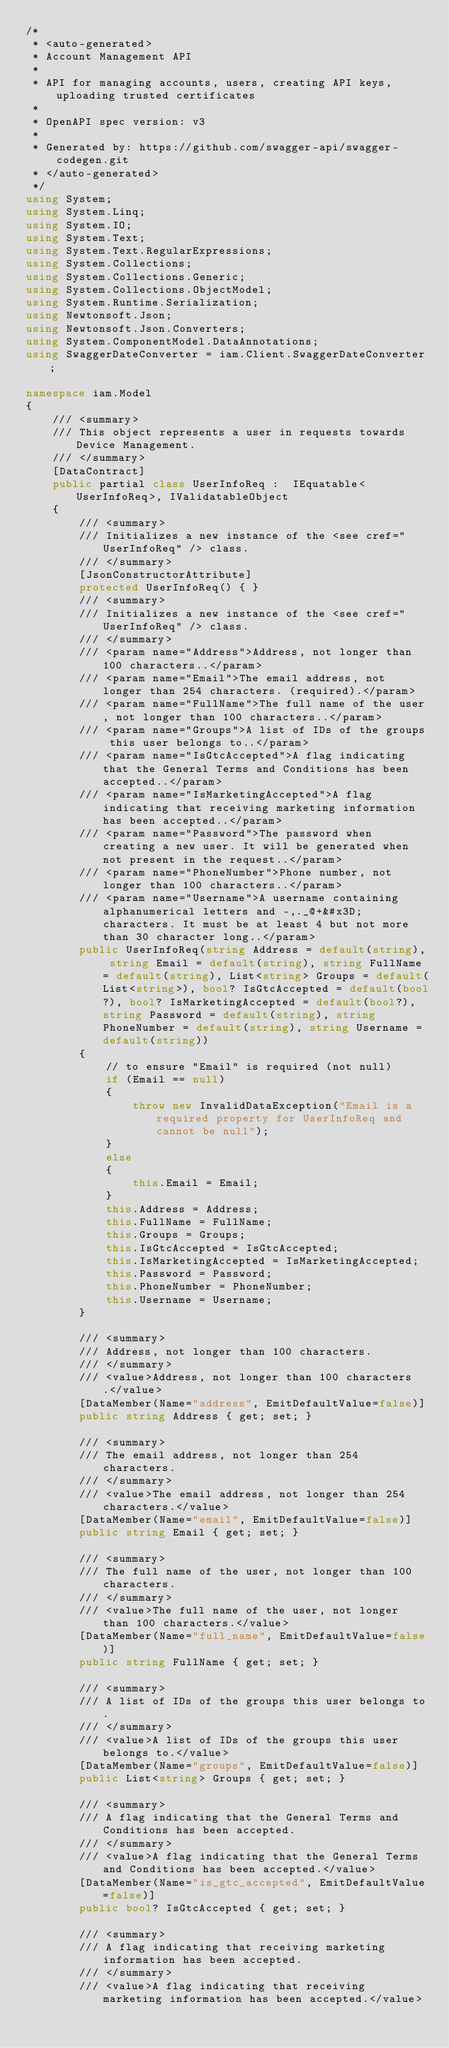Convert code to text. <code><loc_0><loc_0><loc_500><loc_500><_C#_>/* 
 * <auto-generated>
 * Account Management API
 *
 * API for managing accounts, users, creating API keys, uploading trusted certificates
 *
 * OpenAPI spec version: v3
 * 
 * Generated by: https://github.com/swagger-api/swagger-codegen.git
 * </auto-generated>
 */
using System;
using System.Linq;
using System.IO;
using System.Text;
using System.Text.RegularExpressions;
using System.Collections;
using System.Collections.Generic;
using System.Collections.ObjectModel;
using System.Runtime.Serialization;
using Newtonsoft.Json;
using Newtonsoft.Json.Converters;
using System.ComponentModel.DataAnnotations;
using SwaggerDateConverter = iam.Client.SwaggerDateConverter;

namespace iam.Model
{
    /// <summary>
    /// This object represents a user in requests towards Device Management.
    /// </summary>
    [DataContract]
    public partial class UserInfoReq :  IEquatable<UserInfoReq>, IValidatableObject
    {
        /// <summary>
        /// Initializes a new instance of the <see cref="UserInfoReq" /> class.
        /// </summary>
        [JsonConstructorAttribute]
        protected UserInfoReq() { }
        /// <summary>
        /// Initializes a new instance of the <see cref="UserInfoReq" /> class.
        /// </summary>
        /// <param name="Address">Address, not longer than 100 characters..</param>
        /// <param name="Email">The email address, not longer than 254 characters. (required).</param>
        /// <param name="FullName">The full name of the user, not longer than 100 characters..</param>
        /// <param name="Groups">A list of IDs of the groups this user belongs to..</param>
        /// <param name="IsGtcAccepted">A flag indicating that the General Terms and Conditions has been accepted..</param>
        /// <param name="IsMarketingAccepted">A flag indicating that receiving marketing information has been accepted..</param>
        /// <param name="Password">The password when creating a new user. It will be generated when not present in the request..</param>
        /// <param name="PhoneNumber">Phone number, not longer than 100 characters..</param>
        /// <param name="Username">A username containing alphanumerical letters and -,._@+&#x3D; characters. It must be at least 4 but not more than 30 character long..</param>
        public UserInfoReq(string Address = default(string), string Email = default(string), string FullName = default(string), List<string> Groups = default(List<string>), bool? IsGtcAccepted = default(bool?), bool? IsMarketingAccepted = default(bool?), string Password = default(string), string PhoneNumber = default(string), string Username = default(string))
        {
            // to ensure "Email" is required (not null)
            if (Email == null)
            {
                throw new InvalidDataException("Email is a required property for UserInfoReq and cannot be null");
            }
            else
            {
                this.Email = Email;
            }
            this.Address = Address;
            this.FullName = FullName;
            this.Groups = Groups;
            this.IsGtcAccepted = IsGtcAccepted;
            this.IsMarketingAccepted = IsMarketingAccepted;
            this.Password = Password;
            this.PhoneNumber = PhoneNumber;
            this.Username = Username;
        }
        
        /// <summary>
        /// Address, not longer than 100 characters.
        /// </summary>
        /// <value>Address, not longer than 100 characters.</value>
        [DataMember(Name="address", EmitDefaultValue=false)]
        public string Address { get; set; }

        /// <summary>
        /// The email address, not longer than 254 characters.
        /// </summary>
        /// <value>The email address, not longer than 254 characters.</value>
        [DataMember(Name="email", EmitDefaultValue=false)]
        public string Email { get; set; }

        /// <summary>
        /// The full name of the user, not longer than 100 characters.
        /// </summary>
        /// <value>The full name of the user, not longer than 100 characters.</value>
        [DataMember(Name="full_name", EmitDefaultValue=false)]
        public string FullName { get; set; }

        /// <summary>
        /// A list of IDs of the groups this user belongs to.
        /// </summary>
        /// <value>A list of IDs of the groups this user belongs to.</value>
        [DataMember(Name="groups", EmitDefaultValue=false)]
        public List<string> Groups { get; set; }

        /// <summary>
        /// A flag indicating that the General Terms and Conditions has been accepted.
        /// </summary>
        /// <value>A flag indicating that the General Terms and Conditions has been accepted.</value>
        [DataMember(Name="is_gtc_accepted", EmitDefaultValue=false)]
        public bool? IsGtcAccepted { get; set; }

        /// <summary>
        /// A flag indicating that receiving marketing information has been accepted.
        /// </summary>
        /// <value>A flag indicating that receiving marketing information has been accepted.</value></code> 